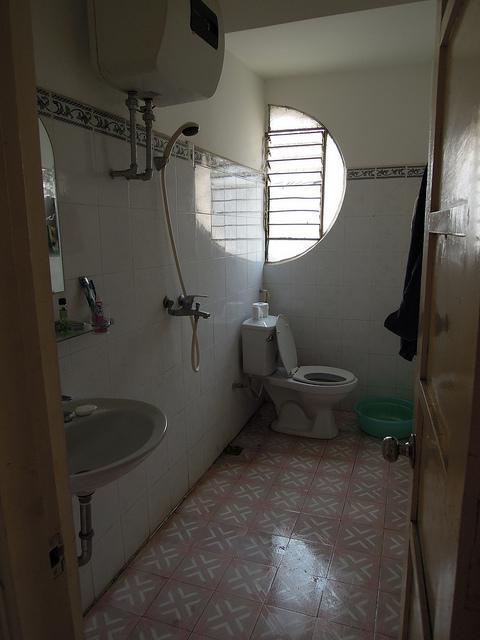How many boats are in the water?
Give a very brief answer. 0. 